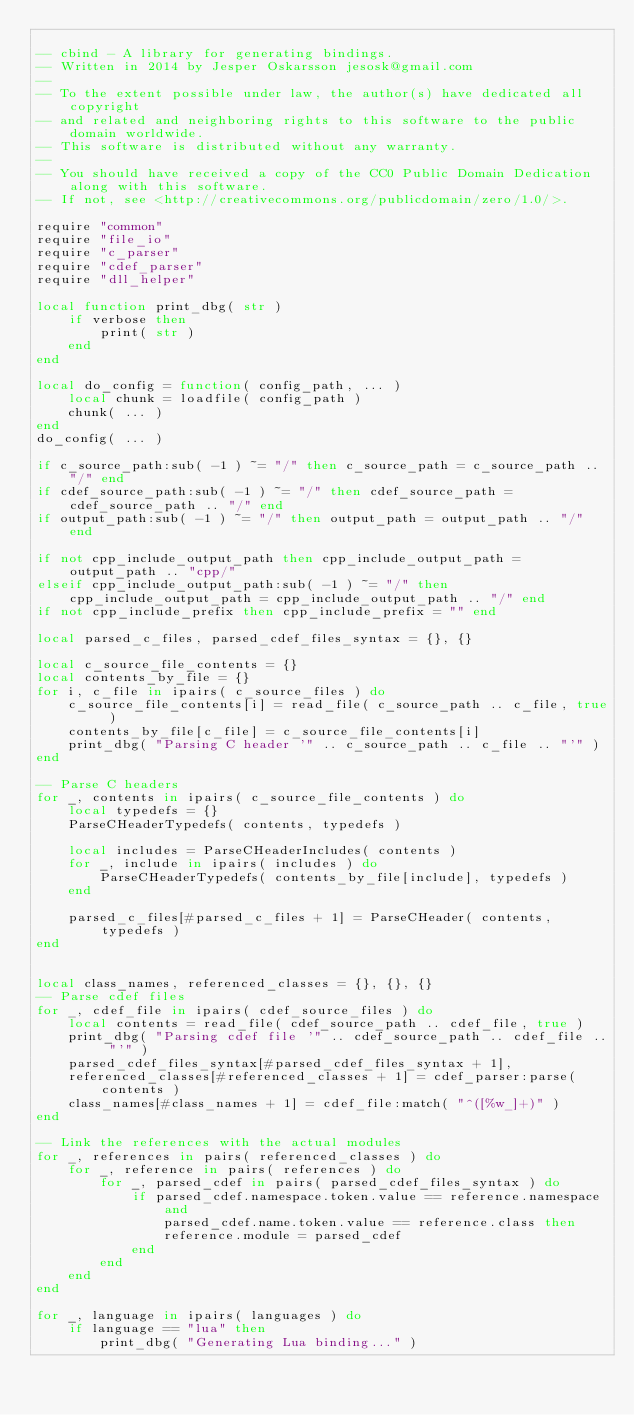Convert code to text. <code><loc_0><loc_0><loc_500><loc_500><_Lua_>
-- cbind - A library for generating bindings.
-- Written in 2014 by Jesper Oskarsson jesosk@gmail.com
--
-- To the extent possible under law, the author(s) have dedicated all copyright
-- and related and neighboring rights to this software to the public domain worldwide.
-- This software is distributed without any warranty.
--
-- You should have received a copy of the CC0 Public Domain Dedication along with this software.
-- If not, see <http://creativecommons.org/publicdomain/zero/1.0/>.

require "common"
require "file_io"
require "c_parser"
require "cdef_parser"
require "dll_helper"

local function print_dbg( str )
	if verbose then
		print( str )
	end
end

local do_config = function( config_path, ... )
	local chunk = loadfile( config_path )
	chunk( ... )
end
do_config( ... )

if c_source_path:sub( -1 ) ~= "/" then c_source_path = c_source_path .. "/" end
if cdef_source_path:sub( -1 ) ~= "/" then cdef_source_path = cdef_source_path .. "/" end
if output_path:sub( -1 ) ~= "/" then output_path = output_path .. "/" end

if not cpp_include_output_path then cpp_include_output_path = output_path .. "cpp/"
elseif cpp_include_output_path:sub( -1 ) ~= "/" then cpp_include_output_path = cpp_include_output_path .. "/" end
if not cpp_include_prefix then cpp_include_prefix = "" end

local parsed_c_files, parsed_cdef_files_syntax = {}, {}

local c_source_file_contents = {}
local contents_by_file = {}
for i, c_file in ipairs( c_source_files ) do
	c_source_file_contents[i] = read_file( c_source_path .. c_file, true )
	contents_by_file[c_file] = c_source_file_contents[i]
	print_dbg( "Parsing C header '" .. c_source_path .. c_file .. "'" )
end

-- Parse C headers
for _, contents in ipairs( c_source_file_contents ) do
	local typedefs = {}
	ParseCHeaderTypedefs( contents, typedefs )

	local includes = ParseCHeaderIncludes( contents )
	for _, include in ipairs( includes ) do
		ParseCHeaderTypedefs( contents_by_file[include], typedefs )
	end

	parsed_c_files[#parsed_c_files + 1] = ParseCHeader( contents, typedefs )
end


local class_names, referenced_classes = {}, {}, {}
-- Parse cdef files
for _, cdef_file in ipairs( cdef_source_files ) do
	local contents = read_file( cdef_source_path .. cdef_file, true )
	print_dbg( "Parsing cdef file '" .. cdef_source_path .. cdef_file .. "'" )
	parsed_cdef_files_syntax[#parsed_cdef_files_syntax + 1],
	referenced_classes[#referenced_classes + 1] = cdef_parser:parse( contents )
	class_names[#class_names + 1] = cdef_file:match( "^([%w_]+)" )
end

-- Link the references with the actual modules
for _, references in pairs( referenced_classes ) do
    for _, reference in pairs( references ) do
        for _, parsed_cdef in pairs( parsed_cdef_files_syntax ) do
            if parsed_cdef.namespace.token.value == reference.namespace and
                parsed_cdef.name.token.value == reference.class then
                reference.module = parsed_cdef
            end
        end
    end
end

for _, language in ipairs( languages ) do
	if language == "lua" then
		print_dbg( "Generating Lua binding..." )</code> 